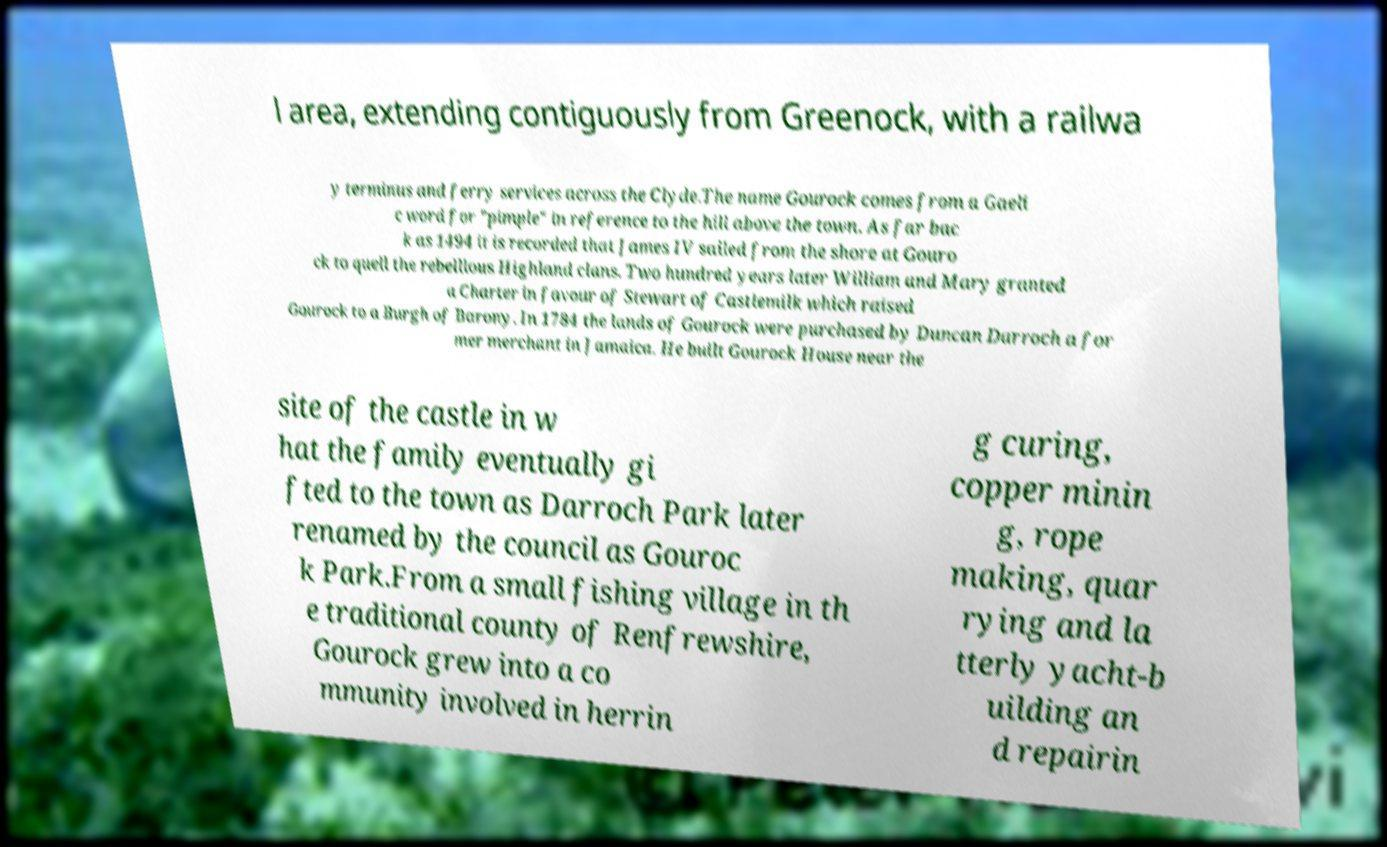For documentation purposes, I need the text within this image transcribed. Could you provide that? l area, extending contiguously from Greenock, with a railwa y terminus and ferry services across the Clyde.The name Gourock comes from a Gaeli c word for "pimple" in reference to the hill above the town. As far bac k as 1494 it is recorded that James IV sailed from the shore at Gouro ck to quell the rebellious Highland clans. Two hundred years later William and Mary granted a Charter in favour of Stewart of Castlemilk which raised Gourock to a Burgh of Barony. In 1784 the lands of Gourock were purchased by Duncan Darroch a for mer merchant in Jamaica. He built Gourock House near the site of the castle in w hat the family eventually gi fted to the town as Darroch Park later renamed by the council as Gouroc k Park.From a small fishing village in th e traditional county of Renfrewshire, Gourock grew into a co mmunity involved in herrin g curing, copper minin g, rope making, quar rying and la tterly yacht-b uilding an d repairin 